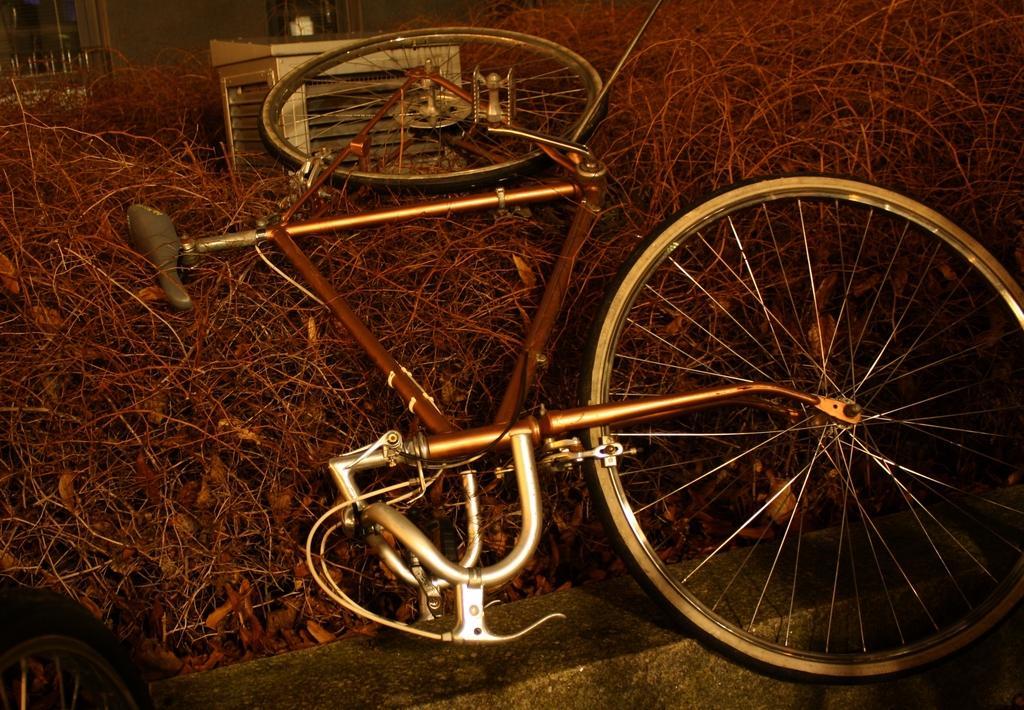In one or two sentences, can you explain what this image depicts? In the center of the image, we can see a bicycle and there is a box on the twigs and we can see a tire and a wall. In the background, we can see windows. 